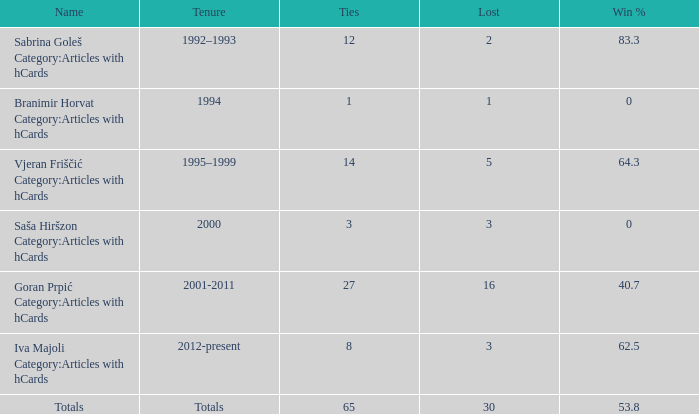Tell me the total number of ties for name of totals and lost more than 30 0.0. 